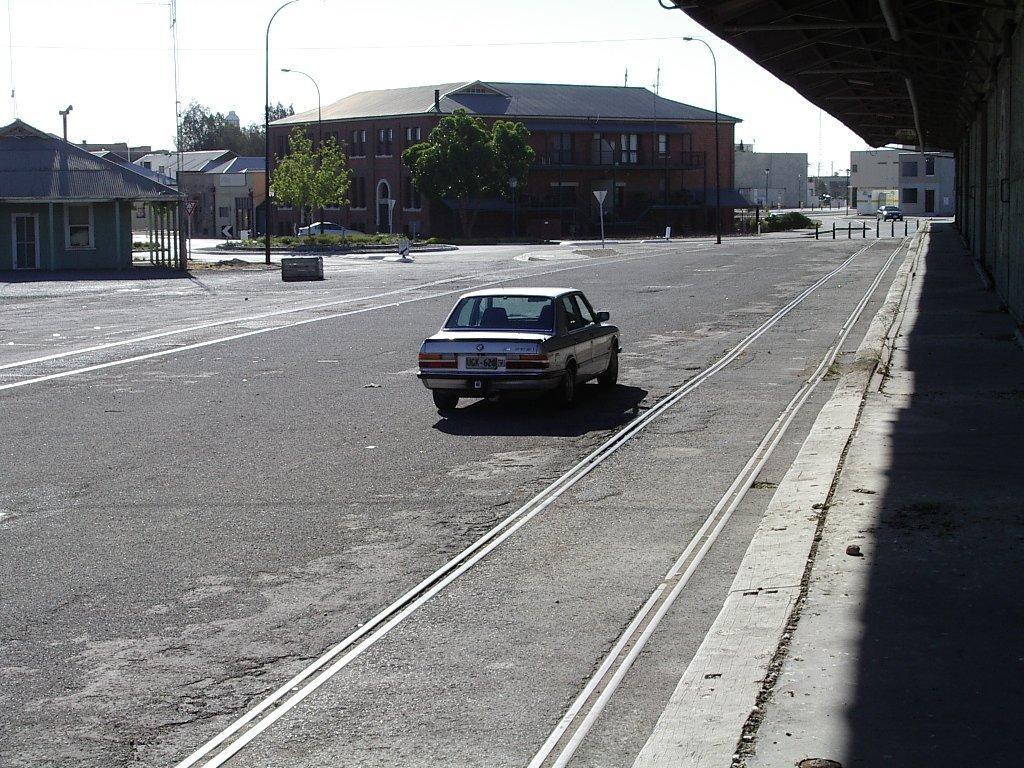In one or two sentences, can you explain what this image depicts? A car is moving on the road, in the middle there are trees and back side of it. There are houses. 